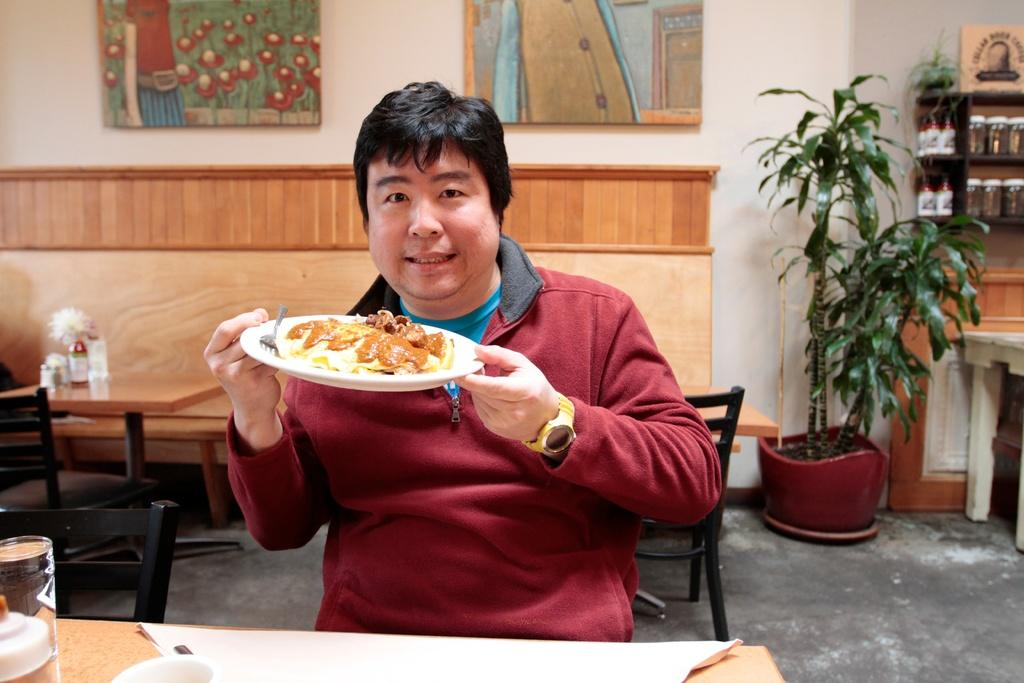Who is present in the image? There is a man in the image. What is the man doing in the image? The man is sitting. What is the man holding in the image? The man is holding a plate. What is on the plate that the man is holding? There is food on the plate, and there is also a fork on the plate. What else can be seen on the table in the image? There is a glass on the table. How does the man cry while holding the plate in the image? There is no indication in the image that the man is crying; he is simply sitting and holding a plate with food and a fork. 